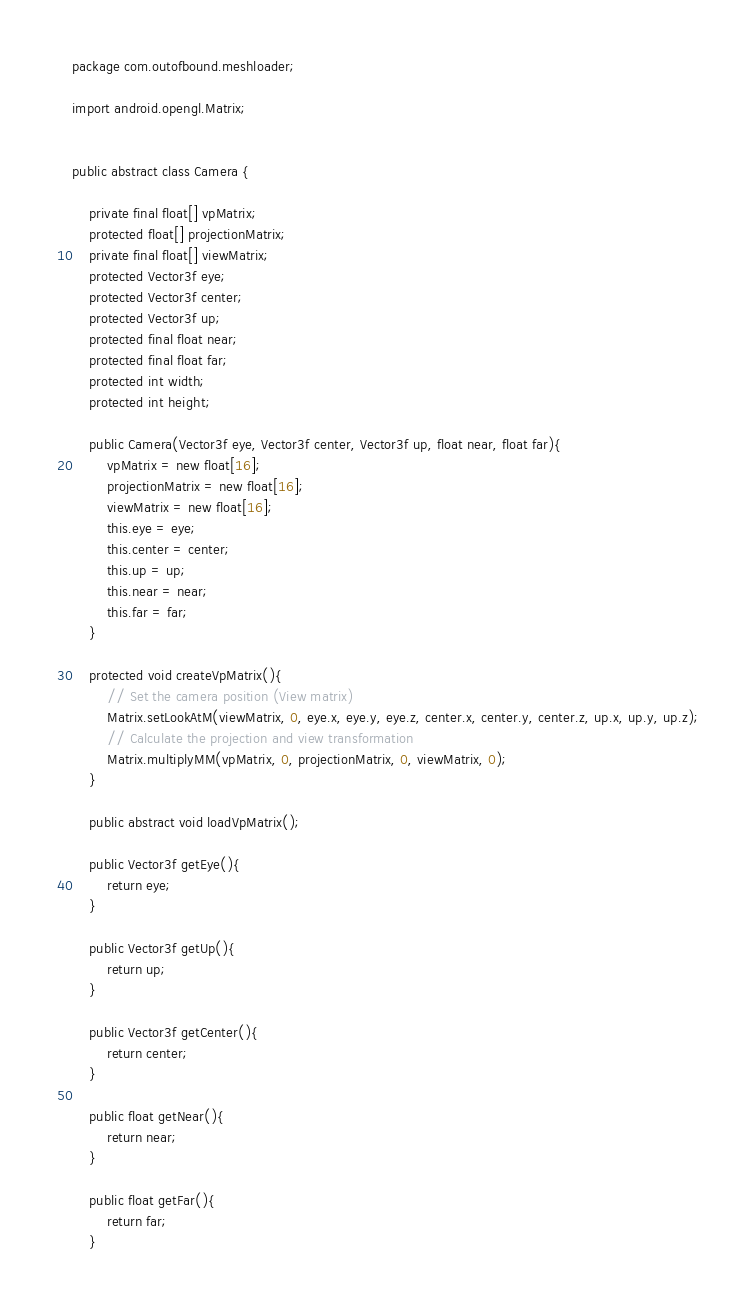Convert code to text. <code><loc_0><loc_0><loc_500><loc_500><_Java_>package com.outofbound.meshloader;

import android.opengl.Matrix;


public abstract class Camera {

    private final float[] vpMatrix;
    protected float[] projectionMatrix;
    private final float[] viewMatrix;
    protected Vector3f eye;
    protected Vector3f center;
    protected Vector3f up;
    protected final float near;
    protected final float far;
    protected int width;
    protected int height;

    public Camera(Vector3f eye, Vector3f center, Vector3f up, float near, float far){
        vpMatrix = new float[16];
        projectionMatrix = new float[16];
        viewMatrix = new float[16];
        this.eye = eye;
        this.center = center;
        this.up = up;
        this.near = near;
        this.far = far;
    }

    protected void createVpMatrix(){
        // Set the camera position (View matrix)
        Matrix.setLookAtM(viewMatrix, 0, eye.x, eye.y, eye.z, center.x, center.y, center.z, up.x, up.y, up.z);
        // Calculate the projection and view transformation
        Matrix.multiplyMM(vpMatrix, 0, projectionMatrix, 0, viewMatrix, 0);
    }

    public abstract void loadVpMatrix();

    public Vector3f getEye(){
        return eye;
    }

    public Vector3f getUp(){
        return up;
    }

    public Vector3f getCenter(){
        return center;
    }

    public float getNear(){
        return near;
    }

    public float getFar(){
        return far;
    }
</code> 